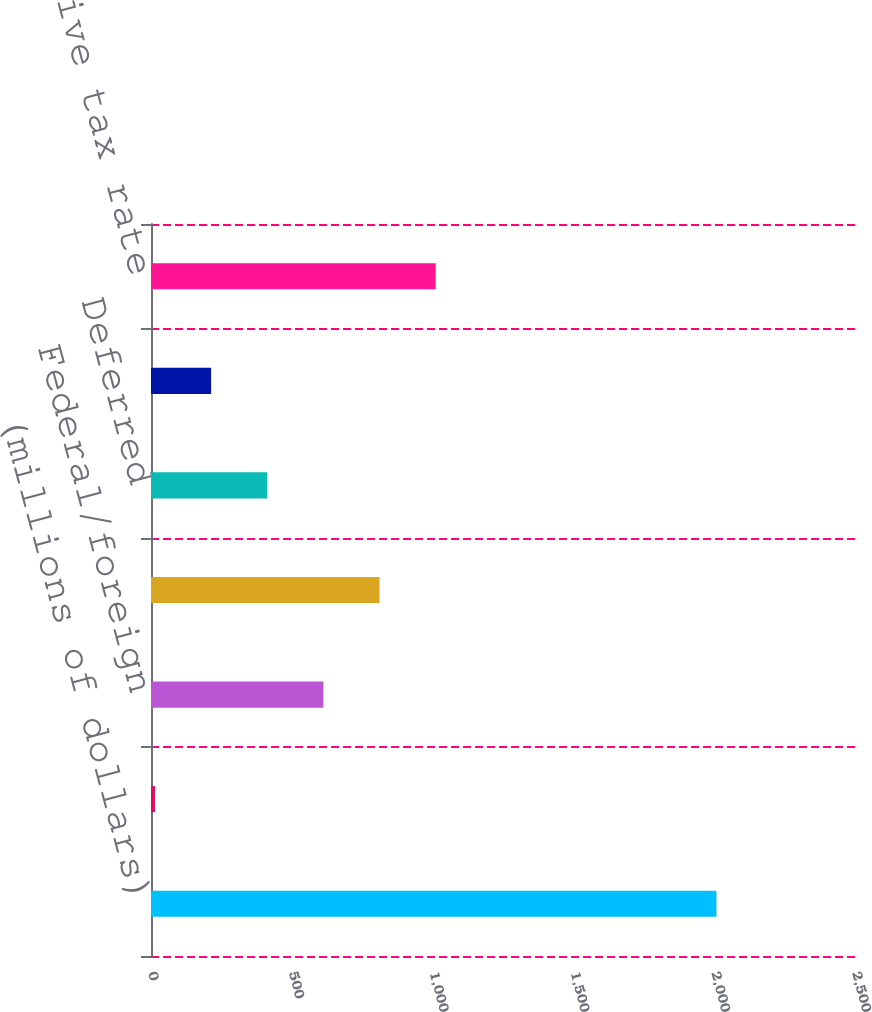Convert chart. <chart><loc_0><loc_0><loc_500><loc_500><bar_chart><fcel>(millions of dollars)<fcel>Earnings (loss) before taxes<fcel>Federal/foreign<fcel>Total current<fcel>Deferred<fcel>Total provision for income<fcel>Effective tax rate<nl><fcel>2008<fcel>14<fcel>612.2<fcel>811.6<fcel>412.8<fcel>213.4<fcel>1011<nl></chart> 